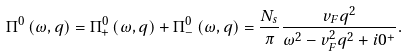<formula> <loc_0><loc_0><loc_500><loc_500>\Pi ^ { 0 } \left ( \omega , q \right ) = \Pi _ { + } ^ { 0 } \left ( \omega , q \right ) + \Pi _ { - } ^ { 0 } \left ( \omega , q \right ) = \frac { N _ { s } } { \pi } \frac { v _ { F } q ^ { 2 } } { \omega ^ { 2 } - v _ { F } ^ { 2 } q ^ { 2 } + i 0 ^ { + } } .</formula> 